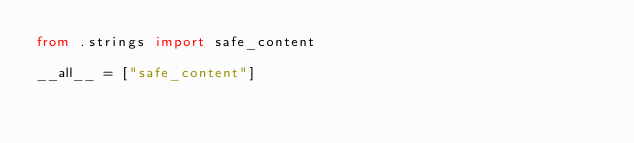Convert code to text. <code><loc_0><loc_0><loc_500><loc_500><_Python_>from .strings import safe_content

__all__ = ["safe_content"]
</code> 